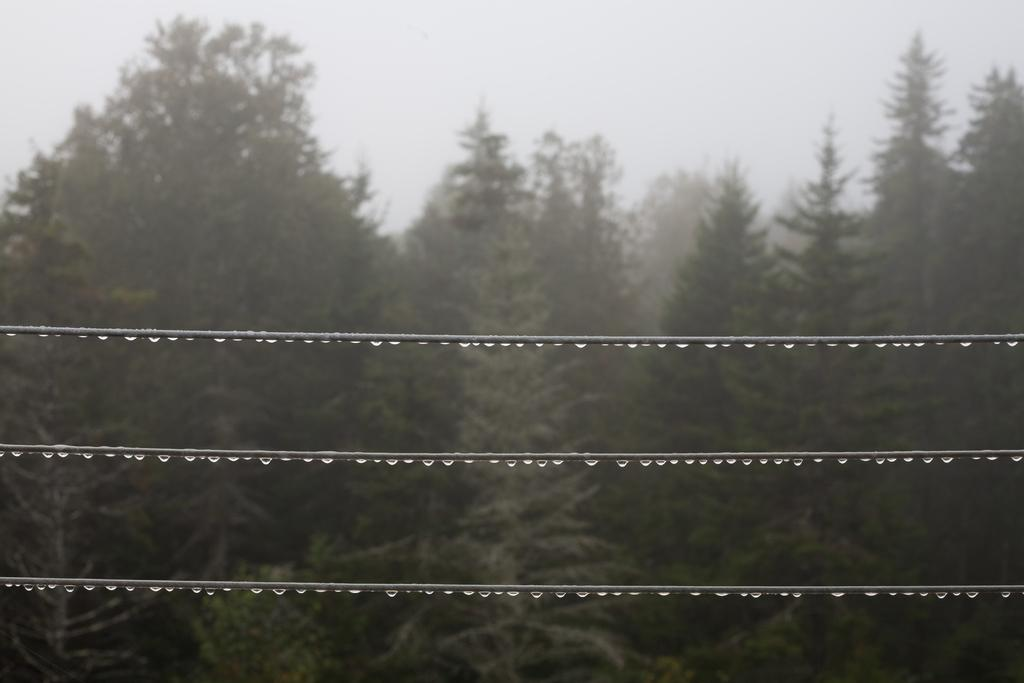What can be seen in the foreground of the image? There are three wire cables in the foreground of the image. What is visible in the background of the image? There is a group of trees and the sky in the background of the image. Can you tell me how many points the bear scored in the image? There is no bear present in the image, so it is not possible to determine how many points it scored. 